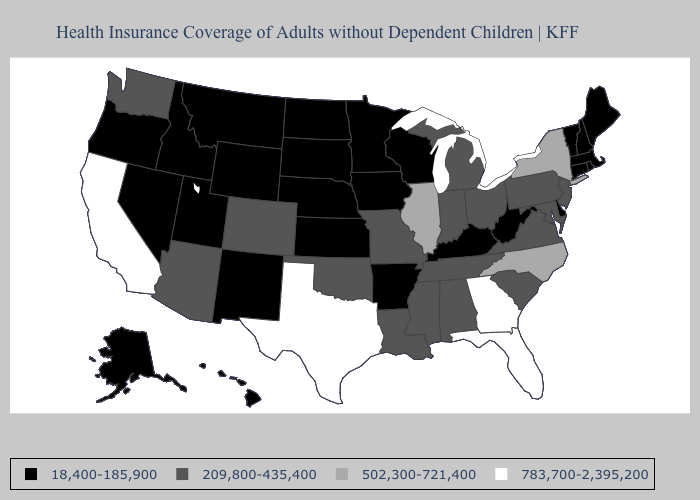What is the value of Mississippi?
Be succinct. 209,800-435,400. Which states have the lowest value in the USA?
Concise answer only. Alaska, Arkansas, Connecticut, Delaware, Hawaii, Idaho, Iowa, Kansas, Kentucky, Maine, Massachusetts, Minnesota, Montana, Nebraska, Nevada, New Hampshire, New Mexico, North Dakota, Oregon, Rhode Island, South Dakota, Utah, Vermont, West Virginia, Wisconsin, Wyoming. What is the value of Ohio?
Answer briefly. 209,800-435,400. Does Minnesota have the lowest value in the USA?
Give a very brief answer. Yes. Among the states that border Kansas , does Missouri have the lowest value?
Answer briefly. No. Does the first symbol in the legend represent the smallest category?
Keep it brief. Yes. Does Alaska have the same value as Mississippi?
Answer briefly. No. Does the first symbol in the legend represent the smallest category?
Answer briefly. Yes. Does Colorado have the lowest value in the West?
Write a very short answer. No. Name the states that have a value in the range 209,800-435,400?
Give a very brief answer. Alabama, Arizona, Colorado, Indiana, Louisiana, Maryland, Michigan, Mississippi, Missouri, New Jersey, Ohio, Oklahoma, Pennsylvania, South Carolina, Tennessee, Virginia, Washington. Does the first symbol in the legend represent the smallest category?
Be succinct. Yes. Does New York have the lowest value in the Northeast?
Keep it brief. No. What is the value of Arkansas?
Short answer required. 18,400-185,900. Name the states that have a value in the range 783,700-2,395,200?
Concise answer only. California, Florida, Georgia, Texas. Name the states that have a value in the range 18,400-185,900?
Give a very brief answer. Alaska, Arkansas, Connecticut, Delaware, Hawaii, Idaho, Iowa, Kansas, Kentucky, Maine, Massachusetts, Minnesota, Montana, Nebraska, Nevada, New Hampshire, New Mexico, North Dakota, Oregon, Rhode Island, South Dakota, Utah, Vermont, West Virginia, Wisconsin, Wyoming. 